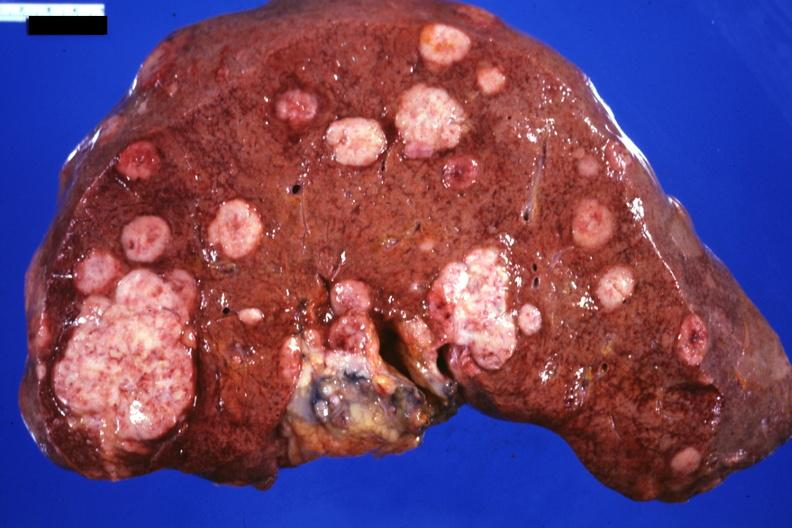s hepatobiliary present?
Answer the question using a single word or phrase. Yes 